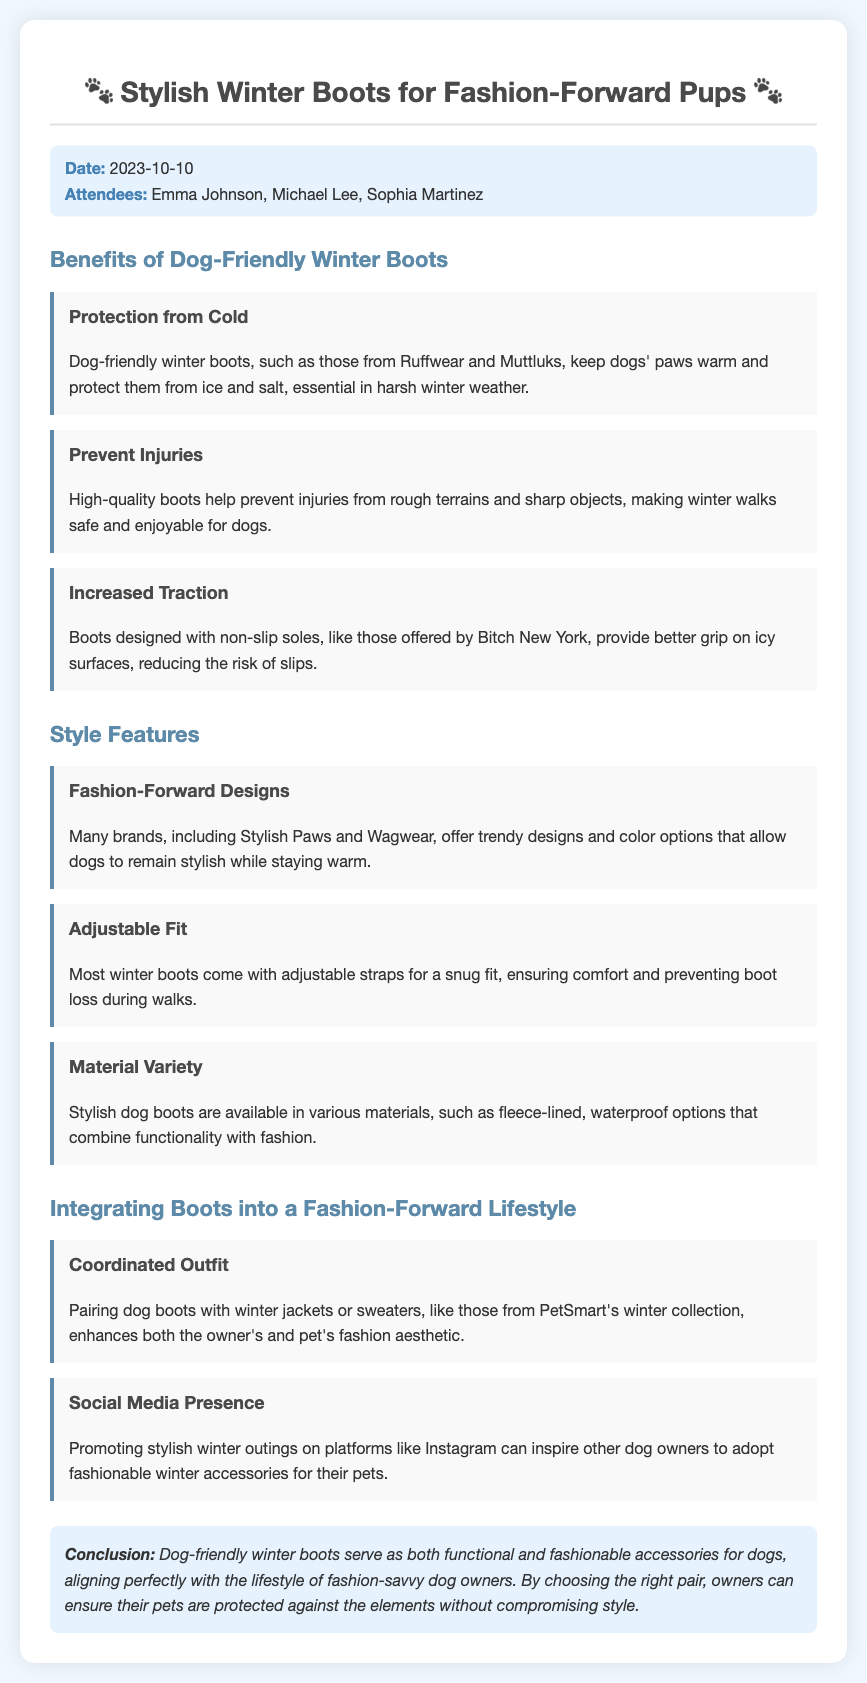What are the names of two dog boot brands mentioned? The document lists Ruffwear and Muttluks as dog boot brands.
Answer: Ruffwear, Muttluks What is the date of the meeting? The date is clearly stated at the beginning of the document.
Answer: 2023-10-10 What feature do many stylish dog boots offer for a better fit? The document mentions that most boots have adjustable straps for comfort.
Answer: Adjustable straps Which aspect of the dog's boots helps with walking on icy surfaces? The document indicates that non-slip soles provide better grip on icy surfaces.
Answer: Non-slip soles What is one way to enhance the fashion aesthetic of dogs according to the meeting? The document suggests pairing boots with winter jackets or sweaters enhances style.
Answer: Coordinated outfit Which social media platform is mentioned for promoting stylish winter outings? The document specifies Instagram as a platform for social media presence.
Answer: Instagram What type of material is mentioned as a stylish option for dog boots? The document notes that fleece-lined, waterproof options combine style with functionality.
Answer: Fleece-lined, waterproof What is a key benefit of high-quality dog boots discussed in the meeting? The document states that high-quality boots help prevent injuries during winter walks.
Answer: Prevent injuries What is the overall conclusion about dog-friendly winter boots? The document concludes that these boots are both functional and fashionable for pets.
Answer: Functional and fashionable 